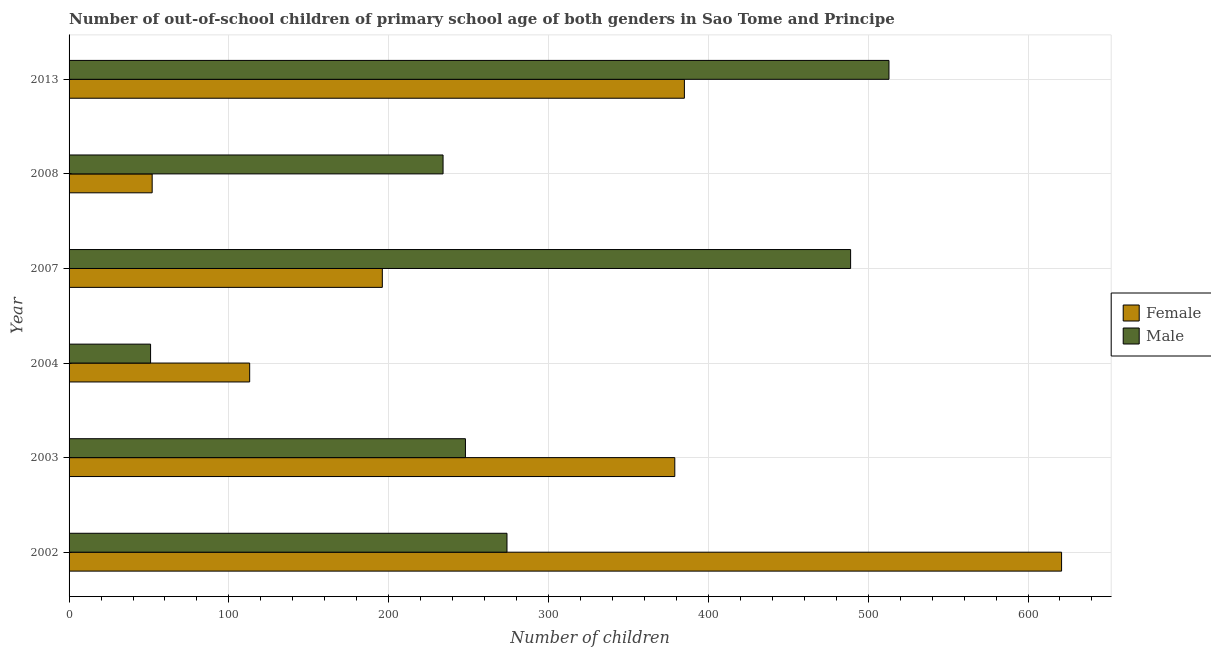How many groups of bars are there?
Give a very brief answer. 6. Are the number of bars per tick equal to the number of legend labels?
Provide a short and direct response. Yes. How many bars are there on the 3rd tick from the top?
Your answer should be very brief. 2. What is the label of the 5th group of bars from the top?
Your response must be concise. 2003. In how many cases, is the number of bars for a given year not equal to the number of legend labels?
Keep it short and to the point. 0. What is the number of male out-of-school students in 2002?
Your answer should be compact. 274. Across all years, what is the maximum number of female out-of-school students?
Give a very brief answer. 621. Across all years, what is the minimum number of female out-of-school students?
Your response must be concise. 52. In which year was the number of female out-of-school students maximum?
Keep it short and to the point. 2002. What is the total number of female out-of-school students in the graph?
Offer a terse response. 1746. What is the difference between the number of male out-of-school students in 2008 and that in 2013?
Your answer should be very brief. -279. What is the difference between the number of female out-of-school students in 2008 and the number of male out-of-school students in 2013?
Your answer should be compact. -461. What is the average number of male out-of-school students per year?
Offer a very short reply. 301.5. In the year 2007, what is the difference between the number of male out-of-school students and number of female out-of-school students?
Provide a short and direct response. 293. In how many years, is the number of female out-of-school students greater than 320 ?
Make the answer very short. 3. What is the ratio of the number of female out-of-school students in 2003 to that in 2007?
Your answer should be compact. 1.93. Is the number of female out-of-school students in 2004 less than that in 2007?
Offer a very short reply. Yes. What is the difference between the highest and the second highest number of female out-of-school students?
Offer a terse response. 236. What is the difference between the highest and the lowest number of female out-of-school students?
Offer a terse response. 569. What does the 1st bar from the top in 2013 represents?
Provide a succinct answer. Male. What does the 2nd bar from the bottom in 2002 represents?
Provide a short and direct response. Male. How many bars are there?
Give a very brief answer. 12. Are all the bars in the graph horizontal?
Give a very brief answer. Yes. Does the graph contain any zero values?
Provide a short and direct response. No. Does the graph contain grids?
Make the answer very short. Yes. How many legend labels are there?
Offer a very short reply. 2. How are the legend labels stacked?
Keep it short and to the point. Vertical. What is the title of the graph?
Offer a very short reply. Number of out-of-school children of primary school age of both genders in Sao Tome and Principe. What is the label or title of the X-axis?
Your answer should be compact. Number of children. What is the Number of children in Female in 2002?
Offer a terse response. 621. What is the Number of children of Male in 2002?
Your answer should be compact. 274. What is the Number of children of Female in 2003?
Ensure brevity in your answer.  379. What is the Number of children in Male in 2003?
Your answer should be compact. 248. What is the Number of children in Female in 2004?
Your response must be concise. 113. What is the Number of children of Female in 2007?
Your answer should be compact. 196. What is the Number of children in Male in 2007?
Provide a short and direct response. 489. What is the Number of children in Female in 2008?
Ensure brevity in your answer.  52. What is the Number of children in Male in 2008?
Provide a succinct answer. 234. What is the Number of children of Female in 2013?
Offer a terse response. 385. What is the Number of children in Male in 2013?
Your answer should be compact. 513. Across all years, what is the maximum Number of children in Female?
Your answer should be compact. 621. Across all years, what is the maximum Number of children of Male?
Your response must be concise. 513. Across all years, what is the minimum Number of children in Female?
Provide a short and direct response. 52. Across all years, what is the minimum Number of children in Male?
Provide a short and direct response. 51. What is the total Number of children in Female in the graph?
Make the answer very short. 1746. What is the total Number of children in Male in the graph?
Ensure brevity in your answer.  1809. What is the difference between the Number of children in Female in 2002 and that in 2003?
Your answer should be very brief. 242. What is the difference between the Number of children in Male in 2002 and that in 2003?
Make the answer very short. 26. What is the difference between the Number of children of Female in 2002 and that in 2004?
Ensure brevity in your answer.  508. What is the difference between the Number of children in Male in 2002 and that in 2004?
Give a very brief answer. 223. What is the difference between the Number of children of Female in 2002 and that in 2007?
Offer a terse response. 425. What is the difference between the Number of children in Male in 2002 and that in 2007?
Offer a terse response. -215. What is the difference between the Number of children of Female in 2002 and that in 2008?
Offer a terse response. 569. What is the difference between the Number of children of Female in 2002 and that in 2013?
Keep it short and to the point. 236. What is the difference between the Number of children in Male in 2002 and that in 2013?
Give a very brief answer. -239. What is the difference between the Number of children of Female in 2003 and that in 2004?
Keep it short and to the point. 266. What is the difference between the Number of children in Male in 2003 and that in 2004?
Keep it short and to the point. 197. What is the difference between the Number of children of Female in 2003 and that in 2007?
Your response must be concise. 183. What is the difference between the Number of children of Male in 2003 and that in 2007?
Offer a terse response. -241. What is the difference between the Number of children of Female in 2003 and that in 2008?
Ensure brevity in your answer.  327. What is the difference between the Number of children in Male in 2003 and that in 2013?
Give a very brief answer. -265. What is the difference between the Number of children in Female in 2004 and that in 2007?
Your answer should be compact. -83. What is the difference between the Number of children of Male in 2004 and that in 2007?
Provide a succinct answer. -438. What is the difference between the Number of children in Male in 2004 and that in 2008?
Make the answer very short. -183. What is the difference between the Number of children in Female in 2004 and that in 2013?
Ensure brevity in your answer.  -272. What is the difference between the Number of children in Male in 2004 and that in 2013?
Your response must be concise. -462. What is the difference between the Number of children in Female in 2007 and that in 2008?
Keep it short and to the point. 144. What is the difference between the Number of children of Male in 2007 and that in 2008?
Your answer should be compact. 255. What is the difference between the Number of children of Female in 2007 and that in 2013?
Your answer should be compact. -189. What is the difference between the Number of children in Female in 2008 and that in 2013?
Provide a succinct answer. -333. What is the difference between the Number of children in Male in 2008 and that in 2013?
Give a very brief answer. -279. What is the difference between the Number of children of Female in 2002 and the Number of children of Male in 2003?
Offer a very short reply. 373. What is the difference between the Number of children of Female in 2002 and the Number of children of Male in 2004?
Your response must be concise. 570. What is the difference between the Number of children in Female in 2002 and the Number of children in Male in 2007?
Your answer should be compact. 132. What is the difference between the Number of children of Female in 2002 and the Number of children of Male in 2008?
Keep it short and to the point. 387. What is the difference between the Number of children in Female in 2002 and the Number of children in Male in 2013?
Your answer should be very brief. 108. What is the difference between the Number of children of Female in 2003 and the Number of children of Male in 2004?
Offer a very short reply. 328. What is the difference between the Number of children of Female in 2003 and the Number of children of Male in 2007?
Keep it short and to the point. -110. What is the difference between the Number of children in Female in 2003 and the Number of children in Male in 2008?
Provide a succinct answer. 145. What is the difference between the Number of children in Female in 2003 and the Number of children in Male in 2013?
Your answer should be compact. -134. What is the difference between the Number of children in Female in 2004 and the Number of children in Male in 2007?
Keep it short and to the point. -376. What is the difference between the Number of children of Female in 2004 and the Number of children of Male in 2008?
Give a very brief answer. -121. What is the difference between the Number of children of Female in 2004 and the Number of children of Male in 2013?
Keep it short and to the point. -400. What is the difference between the Number of children in Female in 2007 and the Number of children in Male in 2008?
Ensure brevity in your answer.  -38. What is the difference between the Number of children in Female in 2007 and the Number of children in Male in 2013?
Your response must be concise. -317. What is the difference between the Number of children of Female in 2008 and the Number of children of Male in 2013?
Give a very brief answer. -461. What is the average Number of children of Female per year?
Your response must be concise. 291. What is the average Number of children in Male per year?
Provide a short and direct response. 301.5. In the year 2002, what is the difference between the Number of children in Female and Number of children in Male?
Your response must be concise. 347. In the year 2003, what is the difference between the Number of children of Female and Number of children of Male?
Give a very brief answer. 131. In the year 2004, what is the difference between the Number of children in Female and Number of children in Male?
Offer a terse response. 62. In the year 2007, what is the difference between the Number of children of Female and Number of children of Male?
Your answer should be compact. -293. In the year 2008, what is the difference between the Number of children in Female and Number of children in Male?
Your answer should be compact. -182. In the year 2013, what is the difference between the Number of children of Female and Number of children of Male?
Ensure brevity in your answer.  -128. What is the ratio of the Number of children in Female in 2002 to that in 2003?
Give a very brief answer. 1.64. What is the ratio of the Number of children of Male in 2002 to that in 2003?
Your response must be concise. 1.1. What is the ratio of the Number of children in Female in 2002 to that in 2004?
Keep it short and to the point. 5.5. What is the ratio of the Number of children in Male in 2002 to that in 2004?
Your response must be concise. 5.37. What is the ratio of the Number of children of Female in 2002 to that in 2007?
Your answer should be compact. 3.17. What is the ratio of the Number of children of Male in 2002 to that in 2007?
Ensure brevity in your answer.  0.56. What is the ratio of the Number of children in Female in 2002 to that in 2008?
Make the answer very short. 11.94. What is the ratio of the Number of children of Male in 2002 to that in 2008?
Give a very brief answer. 1.17. What is the ratio of the Number of children in Female in 2002 to that in 2013?
Your answer should be compact. 1.61. What is the ratio of the Number of children in Male in 2002 to that in 2013?
Your response must be concise. 0.53. What is the ratio of the Number of children of Female in 2003 to that in 2004?
Provide a short and direct response. 3.35. What is the ratio of the Number of children of Male in 2003 to that in 2004?
Ensure brevity in your answer.  4.86. What is the ratio of the Number of children in Female in 2003 to that in 2007?
Make the answer very short. 1.93. What is the ratio of the Number of children of Male in 2003 to that in 2007?
Keep it short and to the point. 0.51. What is the ratio of the Number of children of Female in 2003 to that in 2008?
Give a very brief answer. 7.29. What is the ratio of the Number of children in Male in 2003 to that in 2008?
Provide a succinct answer. 1.06. What is the ratio of the Number of children in Female in 2003 to that in 2013?
Make the answer very short. 0.98. What is the ratio of the Number of children in Male in 2003 to that in 2013?
Give a very brief answer. 0.48. What is the ratio of the Number of children of Female in 2004 to that in 2007?
Provide a succinct answer. 0.58. What is the ratio of the Number of children in Male in 2004 to that in 2007?
Your answer should be compact. 0.1. What is the ratio of the Number of children in Female in 2004 to that in 2008?
Your answer should be compact. 2.17. What is the ratio of the Number of children of Male in 2004 to that in 2008?
Keep it short and to the point. 0.22. What is the ratio of the Number of children of Female in 2004 to that in 2013?
Offer a very short reply. 0.29. What is the ratio of the Number of children of Male in 2004 to that in 2013?
Provide a succinct answer. 0.1. What is the ratio of the Number of children of Female in 2007 to that in 2008?
Provide a succinct answer. 3.77. What is the ratio of the Number of children in Male in 2007 to that in 2008?
Provide a short and direct response. 2.09. What is the ratio of the Number of children of Female in 2007 to that in 2013?
Your response must be concise. 0.51. What is the ratio of the Number of children in Male in 2007 to that in 2013?
Make the answer very short. 0.95. What is the ratio of the Number of children of Female in 2008 to that in 2013?
Keep it short and to the point. 0.14. What is the ratio of the Number of children in Male in 2008 to that in 2013?
Your response must be concise. 0.46. What is the difference between the highest and the second highest Number of children in Female?
Your response must be concise. 236. What is the difference between the highest and the lowest Number of children in Female?
Provide a short and direct response. 569. What is the difference between the highest and the lowest Number of children of Male?
Make the answer very short. 462. 